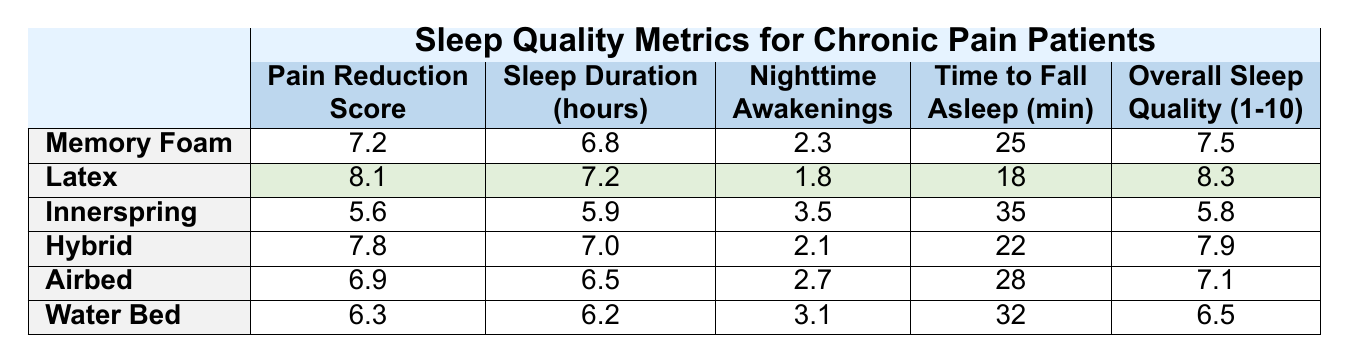What is the Pain Reduction Score for the Latex mattress? Check the table under the 'Pain Reduction Score' column for the 'Latex' row, which shows a score of 8.1.
Answer: 8.1 Which mattress type has the highest Overall Sleep Quality rating? Comparing the values under the 'Overall Sleep Quality' column, 'Latex' has the highest score of 8.3.
Answer: Latex How long do chronic pain patients sleep on average when using Memory Foam mattresses? Refer to the 'Sleep Duration (hours)' column in the row for ‘Memory Foam’, which indicates a duration of 6.8 hours.
Answer: 6.8 What is the average number of nighttime awakenings for all mattress types listed? Calculate the total number of awakenings: 2.3 + 1.8 + 3.5 + 2.1 + 2.7 + 3.1 = 15.5. There are 6 types, so the average is 15.5 / 6 = 2.58.
Answer: 2.58 Is the Time to Fall Asleep shorter for Latex mattresses compared to Innerspring mattresses? The 'Time to Fall Asleep' for Latex is 18 minutes, while Innerspring is 35 minutes, so yes, Latex is shorter by 17 minutes.
Answer: Yes Which mattress type has the lowest Pain Reduction Score and what is that score? Looking at the 'Pain Reduction Score' column, the Innerspring mattress has the lowest score of 5.6.
Answer: 5.6 If a patient using a Hybrid mattress wants to reduce their Time to Fall Asleep to under 20 minutes, how much improvement is needed? The current time is 22 minutes, so to fall asleep in under 20 minutes, they need to improve by 3 minutes.
Answer: 3 minutes What is the difference in Sleep Duration hours between the Latex and Water Bed mattresses? The Sleep Duration for Latex is 7.2 hours and for Water Bed is 6.2 hours. The difference is 7.2 - 6.2 = 1 hour.
Answer: 1 hour Does the Innerspring mattress provide better sleep quality than the Airbed mattress? Check the 'Overall Sleep Quality' scores: Innerspring is 5.8, and Airbed is 7.1; since 5.8 < 7.1, Innerspring does not provide better quality.
Answer: No Which mattress type has the least number of Nighttime Awakenings and what is that number? The fewest awakenings can be found in the 'Nighttime Awakenings' column for Latex, with a total of 1.8.
Answer: 1.8 